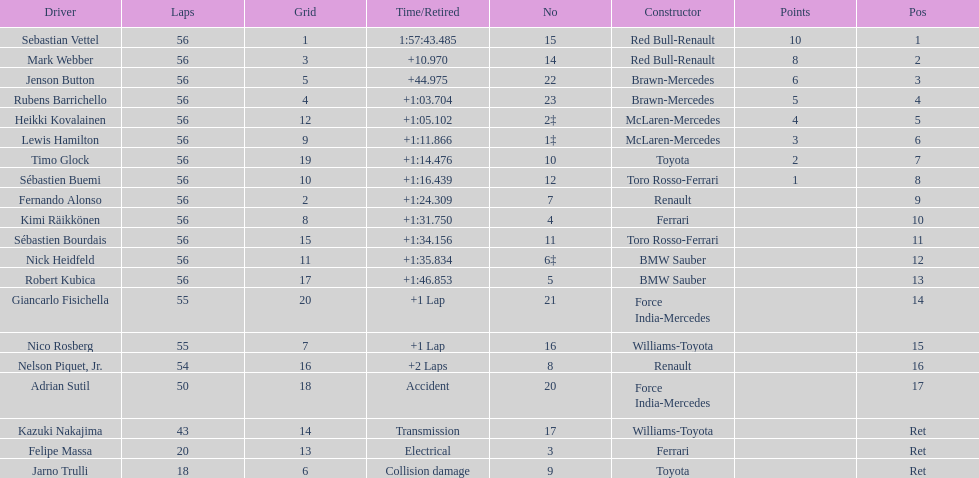What is the name of a driver that ferrari was not a constructor for? Sebastian Vettel. 